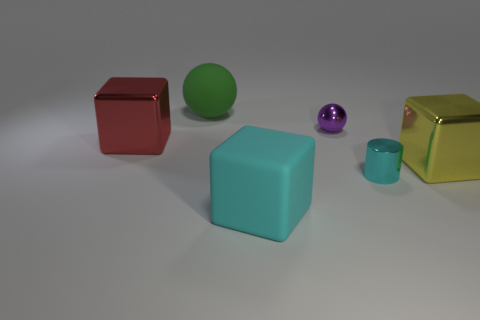Subtract all large red metal cubes. How many cubes are left? 2 Add 1 large green metallic cylinders. How many objects exist? 7 Subtract all cyan cubes. How many cubes are left? 2 Subtract all cylinders. How many objects are left? 5 Subtract all gray cylinders. Subtract all yellow blocks. How many cylinders are left? 1 Subtract 0 blue cubes. How many objects are left? 6 Subtract all small cyan metallic objects. Subtract all purple spheres. How many objects are left? 4 Add 3 small cylinders. How many small cylinders are left? 4 Add 1 red things. How many red things exist? 2 